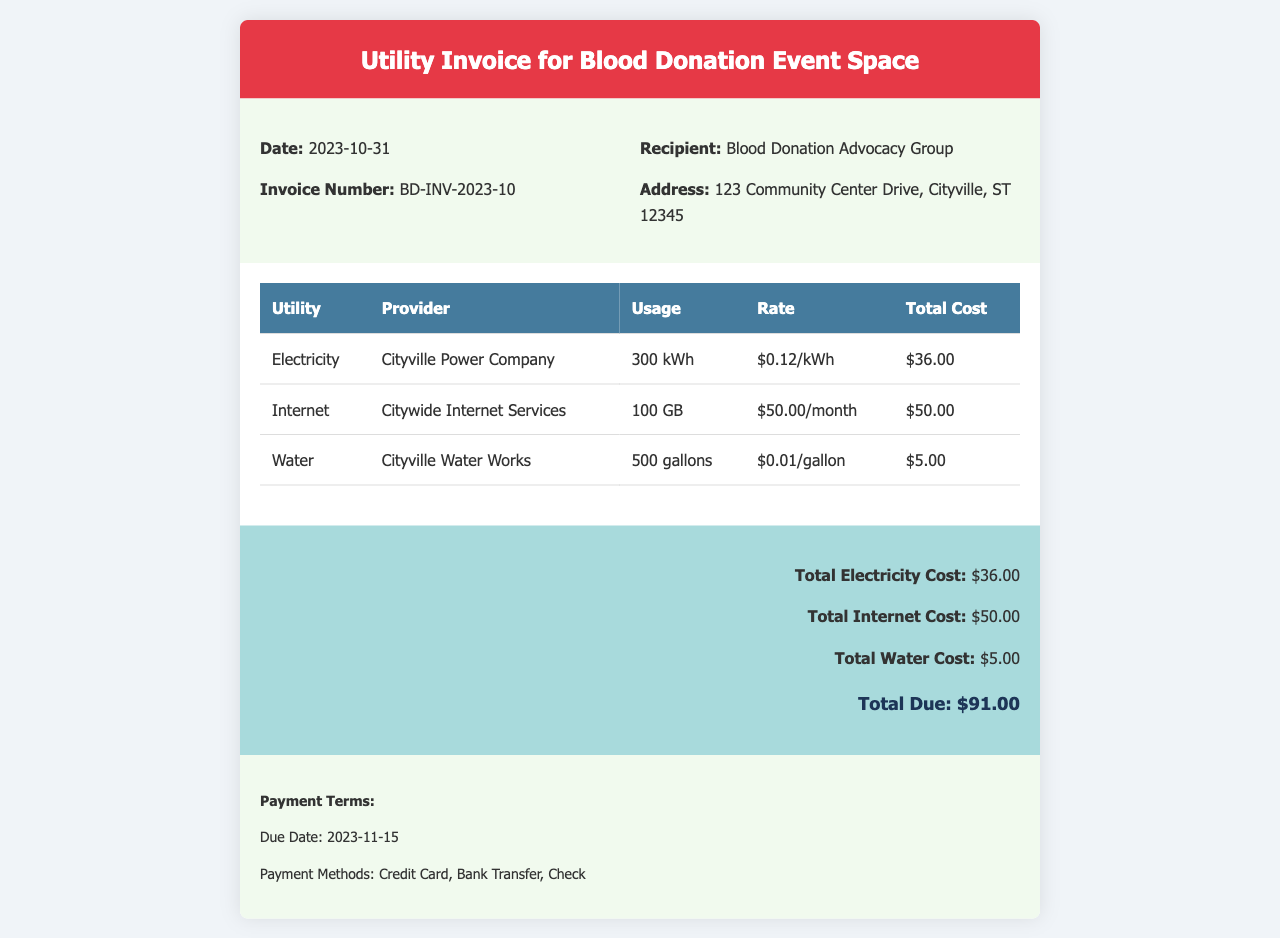What is the invoice number? The invoice number is listed in the document details section, which states "Invoice Number: BD-INV-2023-10."
Answer: BD-INV-2023-10 What is the total due amount? The total due is calculated based on the total costs of electricity, internet, and water, resulting in "Total Due: $91.00."
Answer: $91.00 What is the usage of electricity? The document provides the electricity usage, which is reported as "300 kWh" in the utility table.
Answer: 300 kWh What is the provider for internet services? The document specifies the provider for internet services, which is "Citywide Internet Services."
Answer: Citywide Internet Services What is the due date for payment? The payment terms state the due date as "2023-11-15."
Answer: 2023-11-15 How much does water cost per gallon? The cost per gallon of water is outlined in the utility table as "$0.01/gallon."
Answer: $0.01/gallon How many gallons of water were used? The document lists the total water usage as "500 gallons" in the utilities section.
Answer: 500 gallons What is the total cost for electricity? The total electricity cost is clearly stated as "Total Electricity Cost: $36.00" in the summary area.
Answer: $36.00 What types of payment methods are accepted? The payment terms section indicates the accepted methods as "Credit Card, Bank Transfer, Check."
Answer: Credit Card, Bank Transfer, Check 